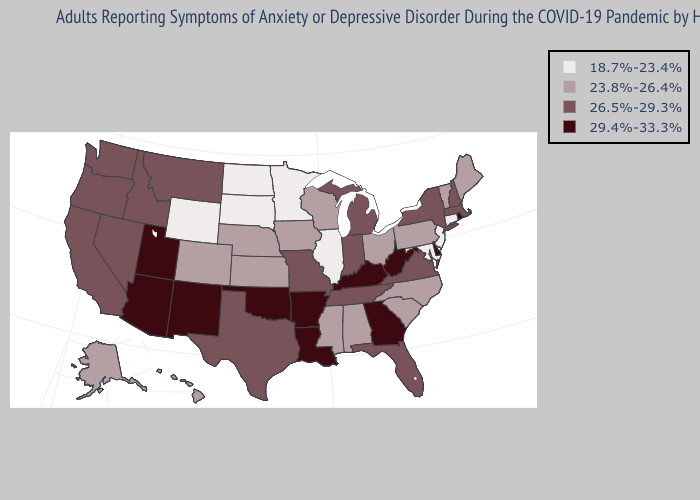Name the states that have a value in the range 23.8%-26.4%?
Quick response, please. Alabama, Alaska, Colorado, Hawaii, Iowa, Kansas, Maine, Mississippi, Nebraska, North Carolina, Ohio, Pennsylvania, South Carolina, Vermont, Wisconsin. Does Hawaii have a higher value than Tennessee?
Answer briefly. No. Which states have the lowest value in the Northeast?
Keep it brief. Connecticut, New Jersey. Among the states that border Michigan , which have the lowest value?
Give a very brief answer. Ohio, Wisconsin. Which states hav the highest value in the Northeast?
Be succinct. Rhode Island. What is the value of Oregon?
Short answer required. 26.5%-29.3%. What is the value of Wyoming?
Short answer required. 18.7%-23.4%. What is the highest value in the West ?
Write a very short answer. 29.4%-33.3%. What is the highest value in the USA?
Write a very short answer. 29.4%-33.3%. What is the lowest value in the MidWest?
Quick response, please. 18.7%-23.4%. Does the map have missing data?
Concise answer only. No. What is the lowest value in the USA?
Concise answer only. 18.7%-23.4%. Does the first symbol in the legend represent the smallest category?
Write a very short answer. Yes. Does Wyoming have the lowest value in the West?
Keep it brief. Yes. 